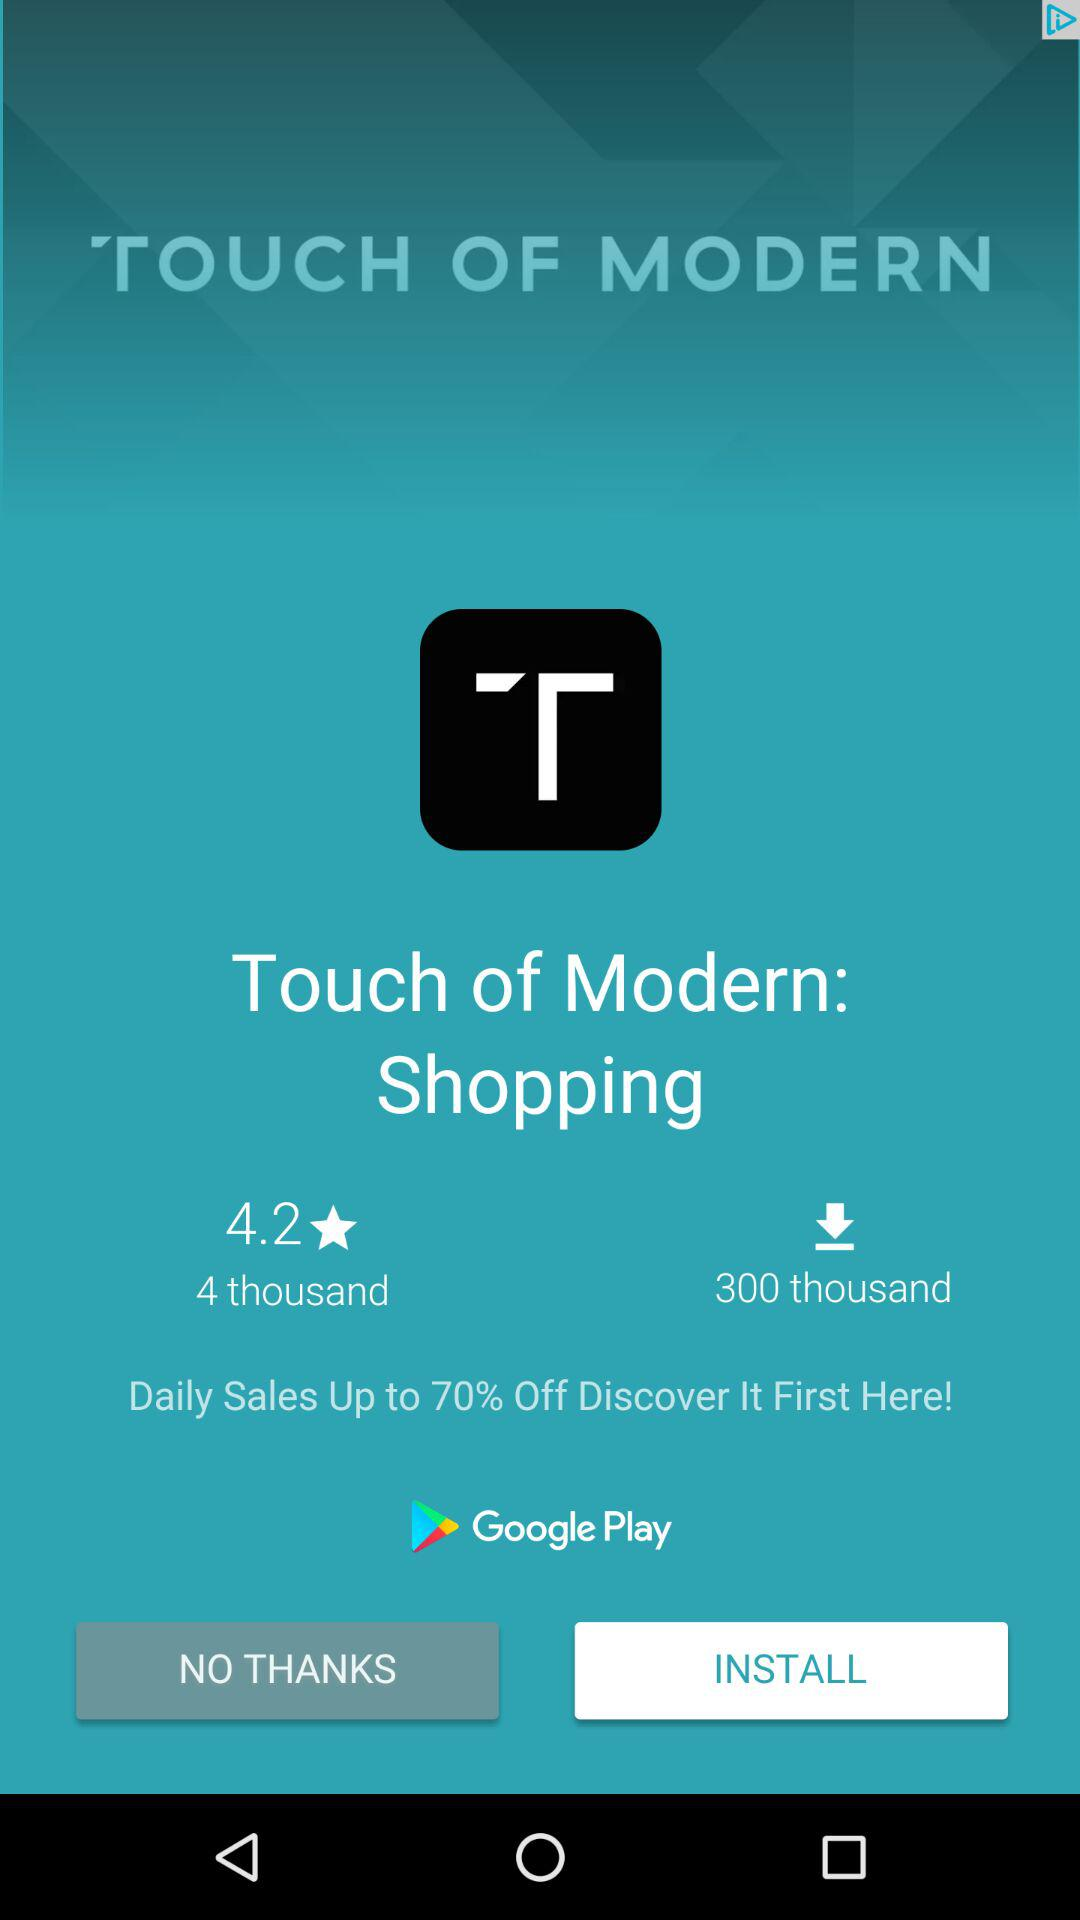How many more downloads does Touch of Modern have than reviews?
Answer the question using a single word or phrase. 296000 